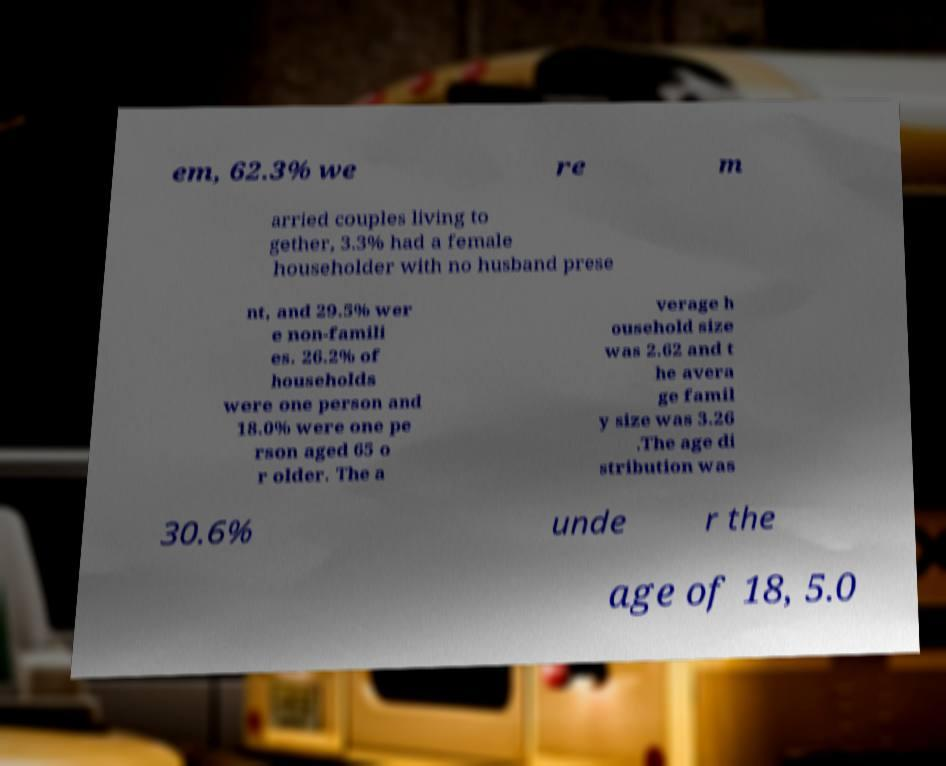There's text embedded in this image that I need extracted. Can you transcribe it verbatim? em, 62.3% we re m arried couples living to gether, 3.3% had a female householder with no husband prese nt, and 29.5% wer e non-famili es. 26.2% of households were one person and 18.0% were one pe rson aged 65 o r older. The a verage h ousehold size was 2.62 and t he avera ge famil y size was 3.26 .The age di stribution was 30.6% unde r the age of 18, 5.0 